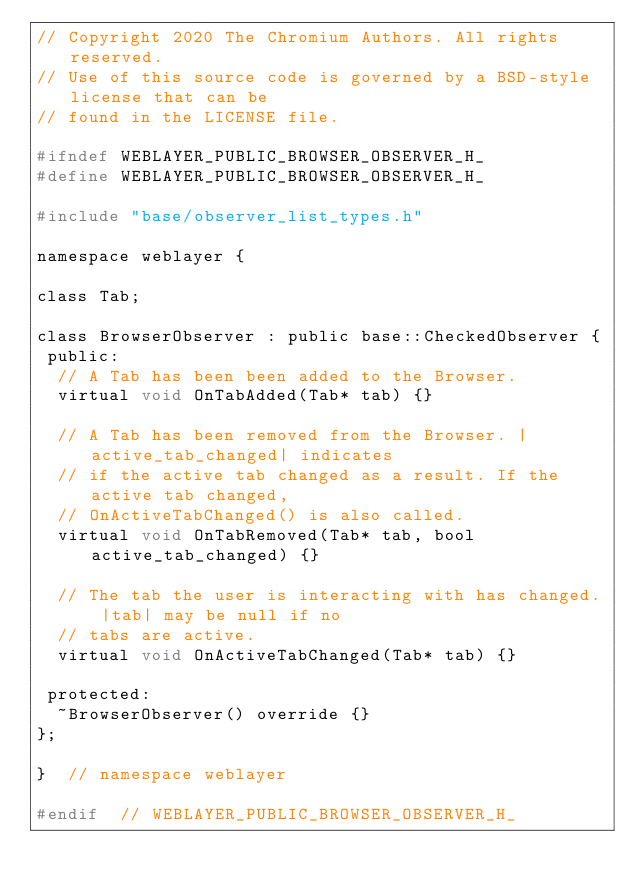Convert code to text. <code><loc_0><loc_0><loc_500><loc_500><_C_>// Copyright 2020 The Chromium Authors. All rights reserved.
// Use of this source code is governed by a BSD-style license that can be
// found in the LICENSE file.

#ifndef WEBLAYER_PUBLIC_BROWSER_OBSERVER_H_
#define WEBLAYER_PUBLIC_BROWSER_OBSERVER_H_

#include "base/observer_list_types.h"

namespace weblayer {

class Tab;

class BrowserObserver : public base::CheckedObserver {
 public:
  // A Tab has been been added to the Browser.
  virtual void OnTabAdded(Tab* tab) {}

  // A Tab has been removed from the Browser. |active_tab_changed| indicates
  // if the active tab changed as a result. If the active tab changed,
  // OnActiveTabChanged() is also called.
  virtual void OnTabRemoved(Tab* tab, bool active_tab_changed) {}

  // The tab the user is interacting with has changed. |tab| may be null if no
  // tabs are active.
  virtual void OnActiveTabChanged(Tab* tab) {}

 protected:
  ~BrowserObserver() override {}
};

}  // namespace weblayer

#endif  // WEBLAYER_PUBLIC_BROWSER_OBSERVER_H_
</code> 